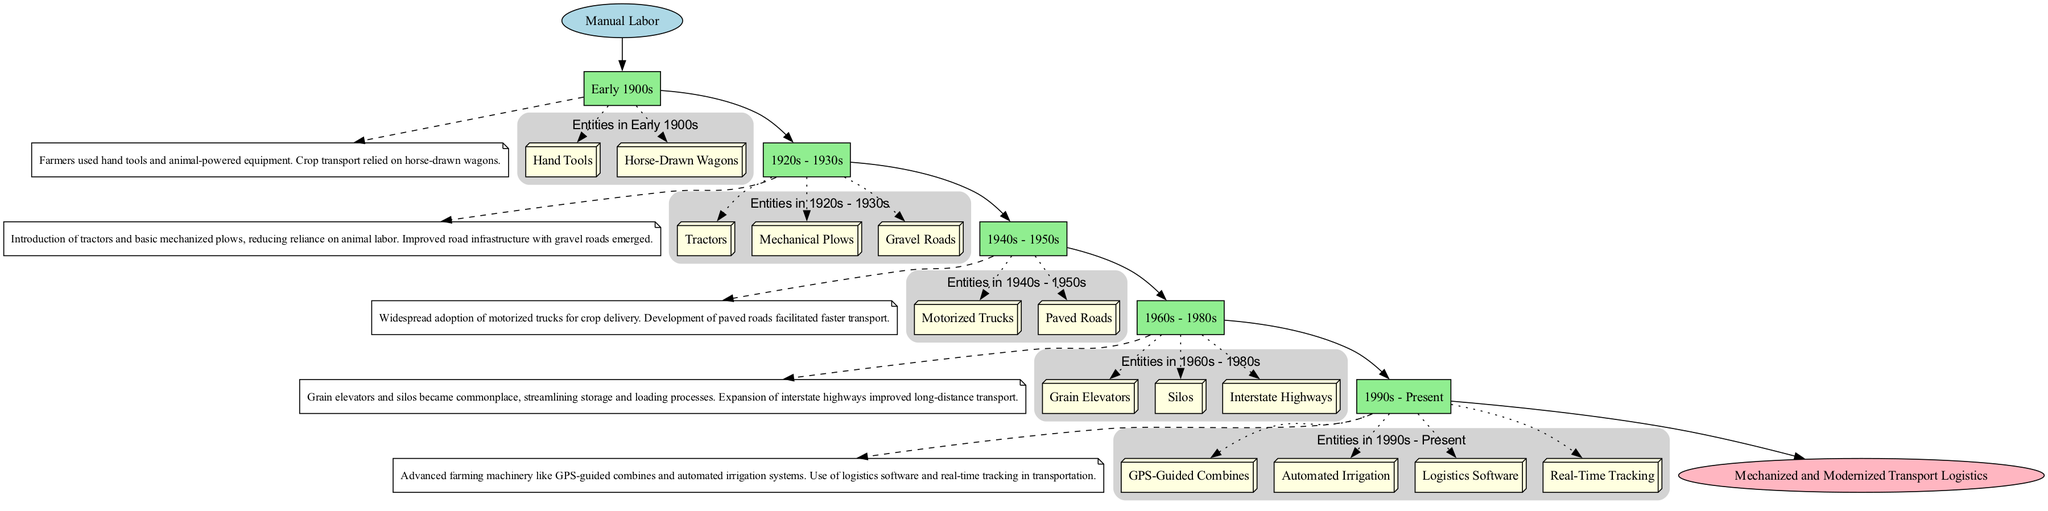What was the primary mode of transport in the early 1900s? According to the diagram, in the early 1900s, farmers used hand tools and horse-drawn wagons as their primary transport methods. Therefore, horse-drawn wagons is the key representation of transport during this period.
Answer: horse-drawn wagons How many stages are depicted in the transformation of transport logistics? The diagram shows five distinct stages of transformation: Early 1900s, 1920s-1930s, 1940s-1950s, 1960s-1980s, and 1990s-Present. Counting these stages gives us the total number.
Answer: five What significant development occurred in the 1940s-1950s? The diagram indicates that the 1940s-1950s period saw a widespread adoption of motorized trucks for crop delivery, which is highlighted directly in the stage description.
Answer: motorized trucks What infrastructure improvement started in the 1920s-1930s? The description mentions that improved road infrastructure, specifically gravel roads, was developed during the 1920s-1930s, enhancing transportation capabilities for farmers.
Answer: gravel roads What automated systems have been integrated into farming since the 1990s? The diagram refers to advanced farming machinery that includes GPS-guided combines and automated irrigation systems, indicating the integration of these technologies into agricultural practices from the 1990s onward.
Answer: GPS-guided combines, automated irrigation Which period marked the introduction of grain elevators? Based on the diagram, the introduction of grain elevators and silos became common during the 1960s-1980s, as noted in the period description.
Answer: 1960s-1980s How does the diagram illustrate the end of the transport logistics transformation? The diagram presents an “End” node that states the final result of transformation is "Mechanized and Modernized Transport Logistics," indicating that this evolution leads to contemporary logistics methods in transport.
Answer: Mechanized and Modernized Transport Logistics Which entities are associated with the 1940s-1950s stage? According to the entities listed under the 1940s-1950s stage, the main entities are motorized trucks and paved roads, depicting the technological advancements in transport during that time.
Answer: motorized trucks, paved roads 